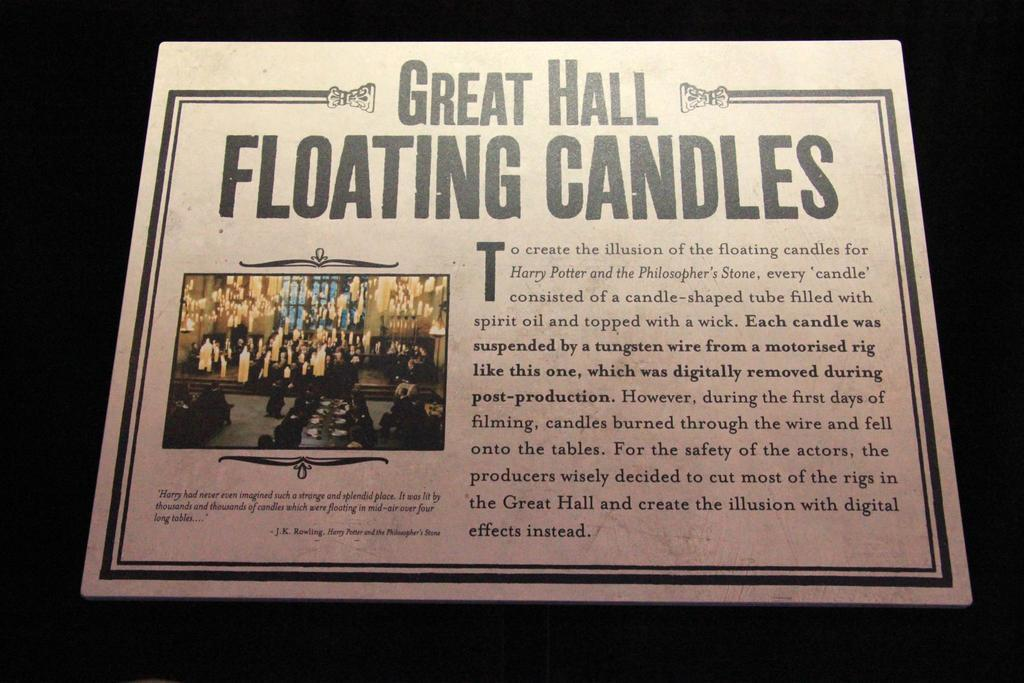<image>
Present a compact description of the photo's key features. An advertisement with the title, Great Hall Floating Candles. 